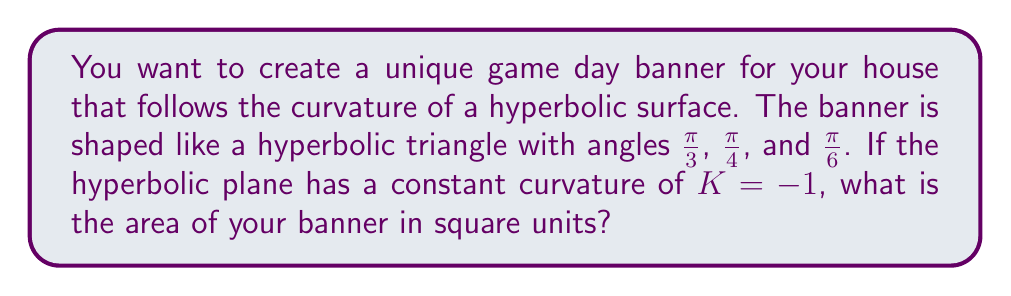Provide a solution to this math problem. Let's approach this step-by-step using the Gauss-Bonnet theorem for hyperbolic geometry:

1) In hyperbolic geometry, the area $A$ of a triangle is given by:

   $$A = \pi - (\alpha + \beta + \gamma)$$

   where $\alpha$, $\beta$, and $\gamma$ are the angles of the triangle, and the curvature $K = -1$.

2) We're given the angles of the hyperbolic triangle:
   $\alpha = \frac{\pi}{3}$, $\beta = \frac{\pi}{4}$, and $\gamma = \frac{\pi}{6}$

3) Let's substitute these into our formula:

   $$A = \pi - (\frac{\pi}{3} + \frac{\pi}{4} + \frac{\pi}{6})$$

4) Simplify the fraction in the parentheses:

   $$A = \pi - (\frac{4\pi}{12} + \frac{3\pi}{12} + \frac{2\pi}{12})$$
   $$A = \pi - \frac{9\pi}{12}$$

5) Subtract the fractions:

   $$A = \frac{12\pi}{12} - \frac{9\pi}{12} = \frac{3\pi}{12}$$

6) Simplify the final fraction:

   $$A = \frac{\pi}{4}$$

Therefore, the area of your hyperbolic game day banner is $\frac{\pi}{4}$ square units.
Answer: $\frac{\pi}{4}$ square units 